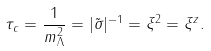Convert formula to latex. <formula><loc_0><loc_0><loc_500><loc_500>\tau _ { c } = \frac { 1 } { m ^ { 2 } _ { \Lambda } } = | \tilde { \sigma } | ^ { - 1 } = \xi ^ { 2 } = \xi ^ { z } .</formula> 